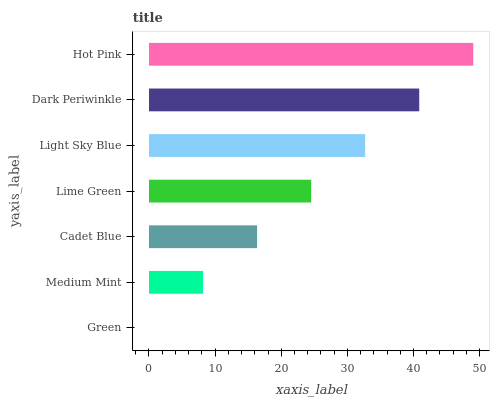Is Green the minimum?
Answer yes or no. Yes. Is Hot Pink the maximum?
Answer yes or no. Yes. Is Medium Mint the minimum?
Answer yes or no. No. Is Medium Mint the maximum?
Answer yes or no. No. Is Medium Mint greater than Green?
Answer yes or no. Yes. Is Green less than Medium Mint?
Answer yes or no. Yes. Is Green greater than Medium Mint?
Answer yes or no. No. Is Medium Mint less than Green?
Answer yes or no. No. Is Lime Green the high median?
Answer yes or no. Yes. Is Lime Green the low median?
Answer yes or no. Yes. Is Dark Periwinkle the high median?
Answer yes or no. No. Is Medium Mint the low median?
Answer yes or no. No. 